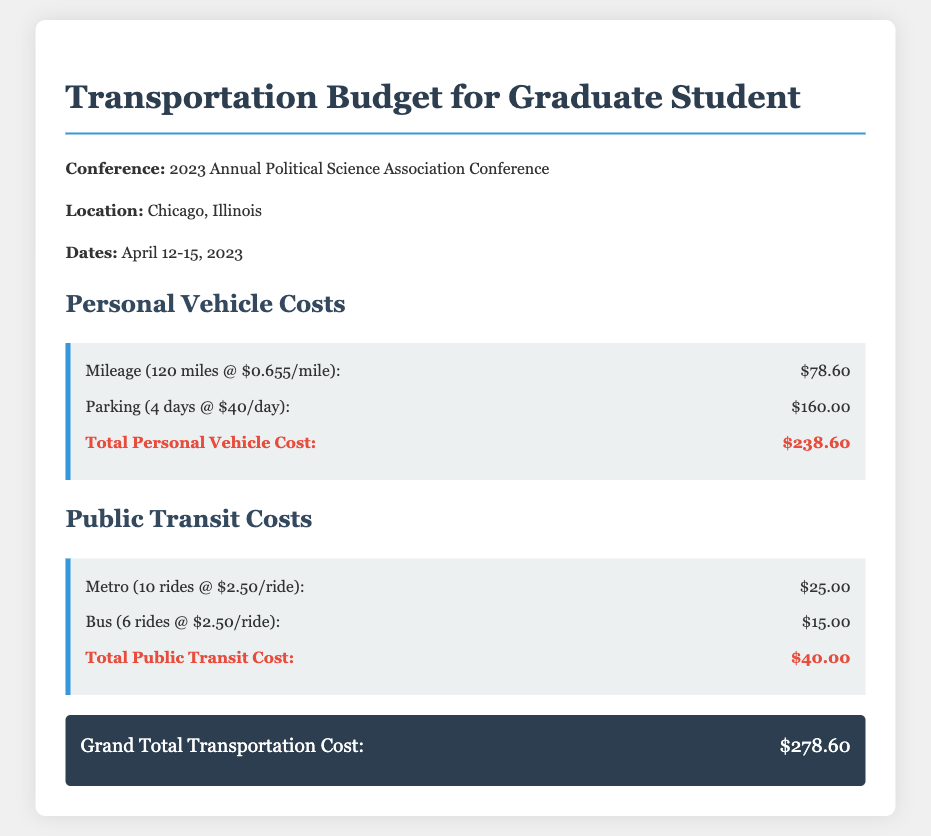What is the conference name? The conference name is provided in the first few lines of the document and is "2023 Annual Political Science Association Conference."
Answer: 2023 Annual Political Science Association Conference What is the location of the conference? The location where the conference is held is mentioned in the document as "Chicago, Illinois."
Answer: Chicago, Illinois What are the dates of the conference? The range of dates for the conference is specified in the document as "April 12-15, 2023."
Answer: April 12-15, 2023 What is the cost of mileage? The mileage cost is detailed in the section about personal vehicle costs, which is "$78.60."
Answer: $78.60 How much did the parking cost? Parking costs are given in the document as a total of "$160.00" for the duration of the conference.
Answer: $160.00 What is the total cost of public transit? The total cost for public transit is summed up in the corresponding section and is "$40.00."
Answer: $40.00 What is the grand total transportation cost? The grand total is calculated and presented at the end of the document as "$278.60."
Answer: $278.60 How many metro rides were taken? The number of metro rides mentioned is "10 rides" in the public transit section.
Answer: 10 rides How much does each bus ride cost? The document states that each bus ride costs "$2.50."
Answer: $2.50 